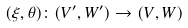<formula> <loc_0><loc_0><loc_500><loc_500>( \xi , \theta ) \colon ( V ^ { \prime } , W ^ { \prime } ) \rightarrow ( V , W )</formula> 